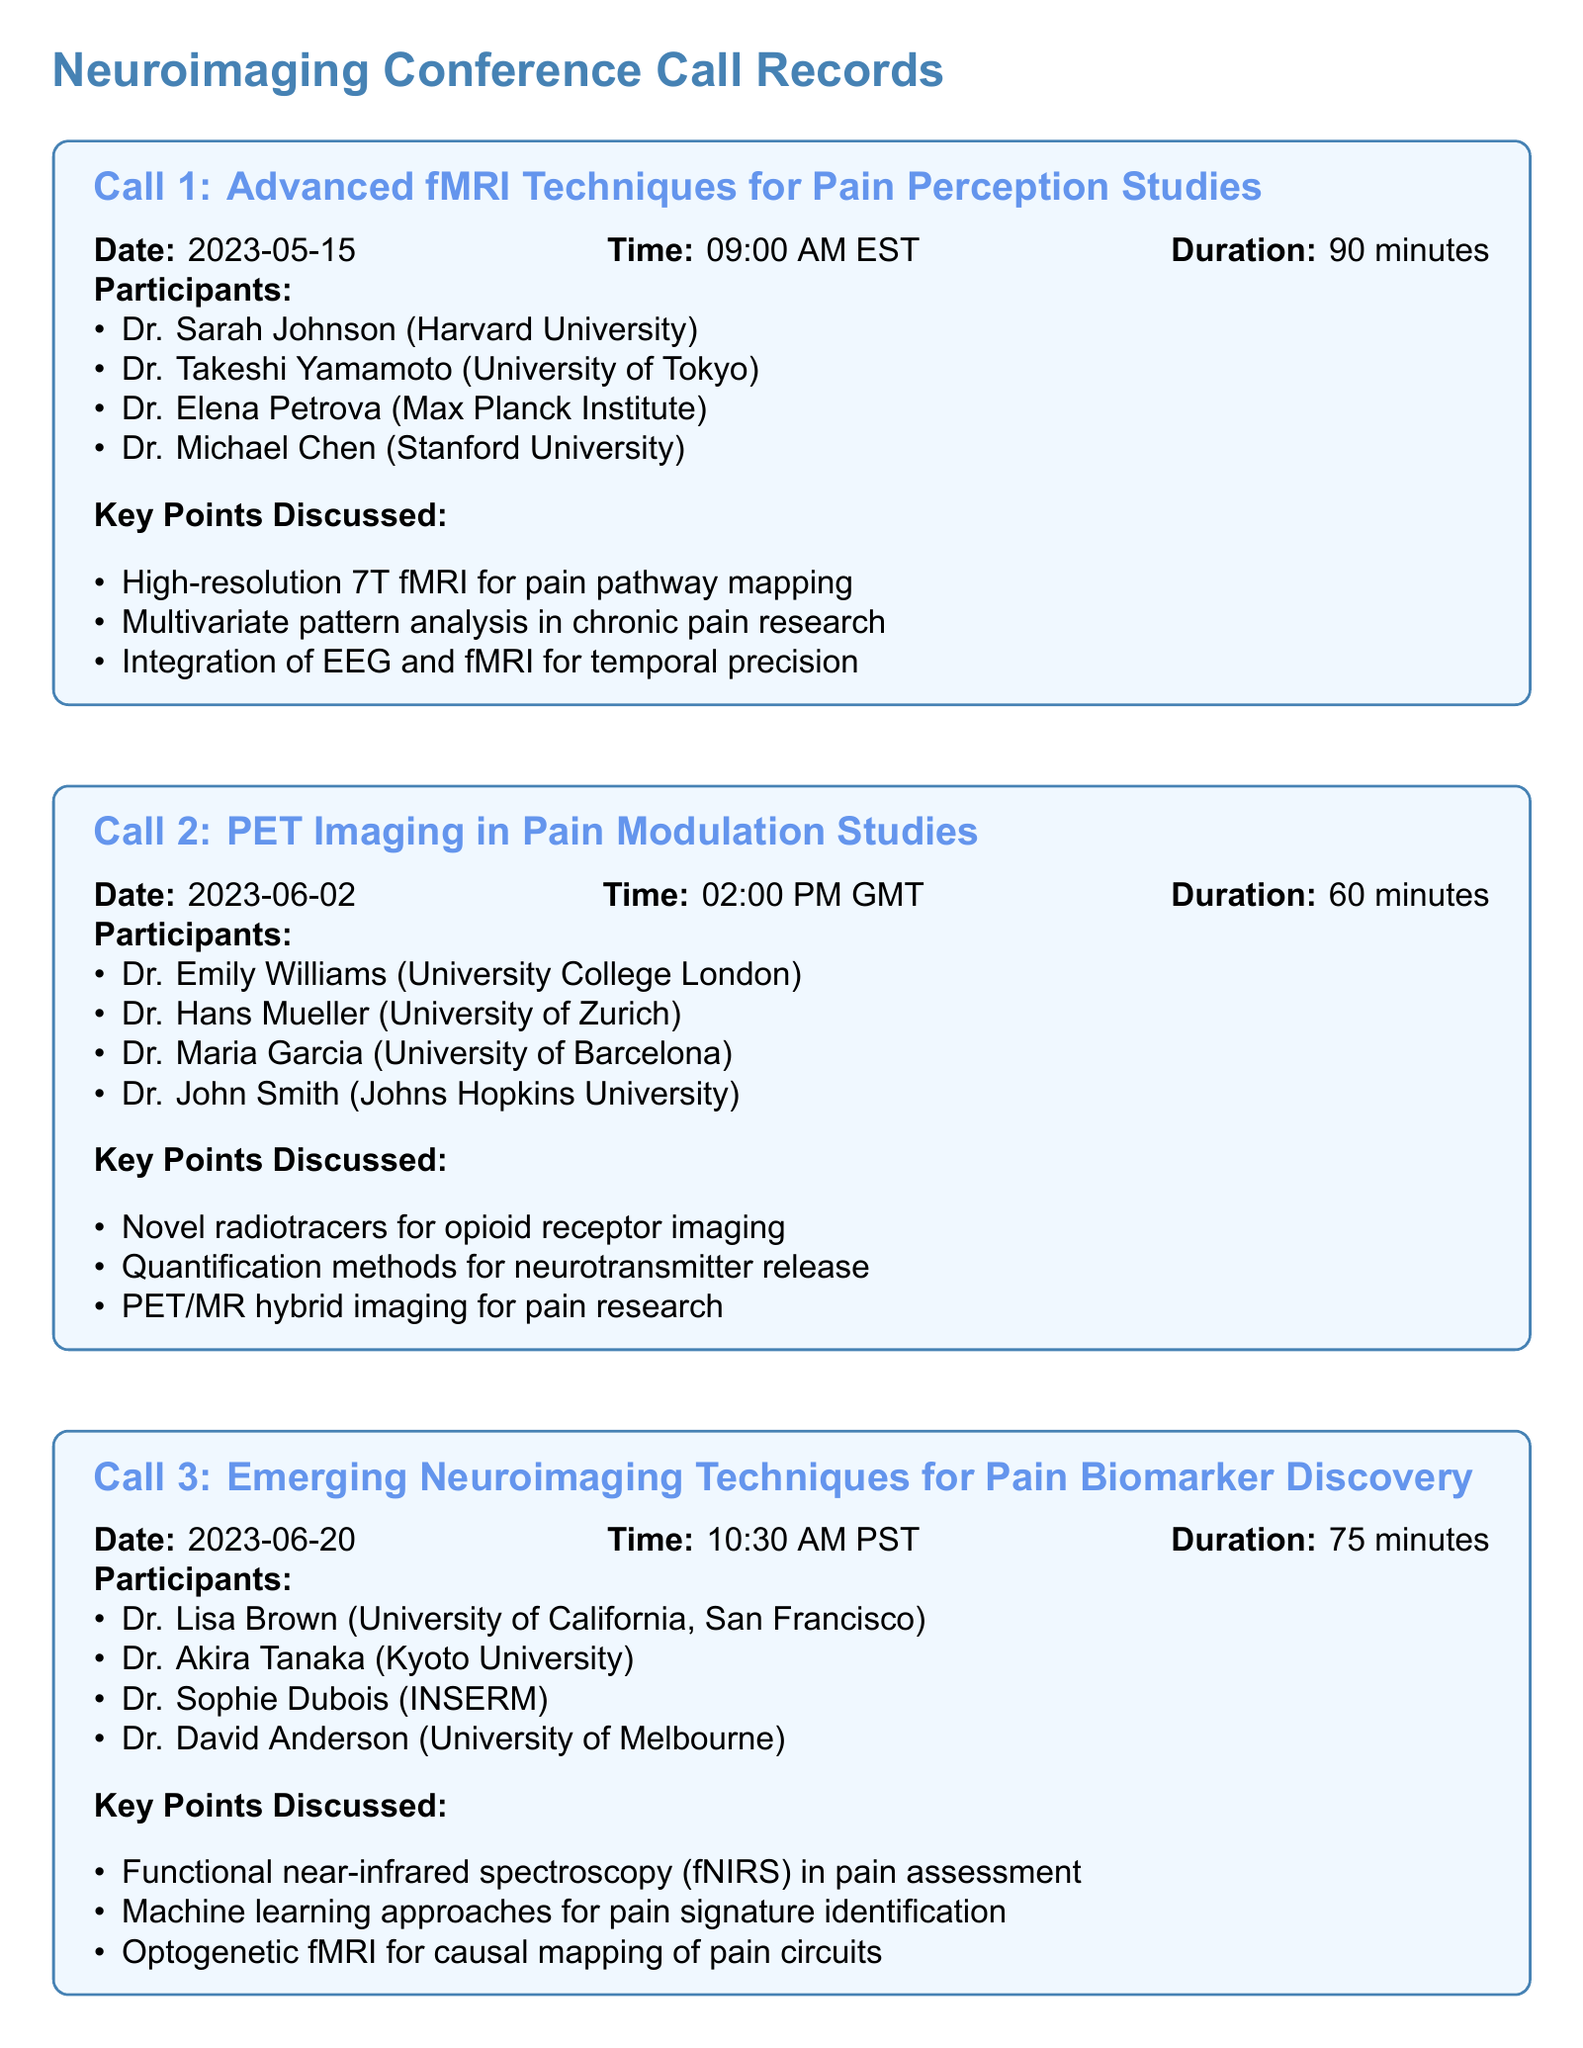What is the date of Call 1? The date of Call 1 is explicitly mentioned in the records.
Answer: 2023-05-15 Who is one of the participants in Call 2? The participants of Call 2 are listed, and any of those names would be correct.
Answer: Dr. Emily Williams What is the duration of Call 3? The duration of Call 3 can be found in the details of the call.
Answer: 75 minutes What neuroimaging technique was discussed in Call 1? The key points discussed in Call 1 include several neuroimaging techniques, one of which is specifically stated.
Answer: 7T fMRI Which university is Dr. Hans Mueller affiliated with? Dr. Hans Mueller's affiliation is listed among the participants for Call 2.
Answer: University of Zurich What hybrid imaging technique was mentioned in Call 2? The key points discussed in Call 2 include specific imaging techniques, including one that involves two modalities.
Answer: PET/MR hybrid imaging How many participants were in Call 3? The number of participants in Call 3 can be counted from the list provided.
Answer: 4 What was the focus of discussions in Call 1? The key points in Call 1 highlight the main focus during that call, emphasizing certain techniques.
Answer: Pain pathway mapping What is the time of Call 2 in UTC? The time of Call 2 is clearly stated in the record as converted to GMT.
Answer: 02:00 PM GMT 